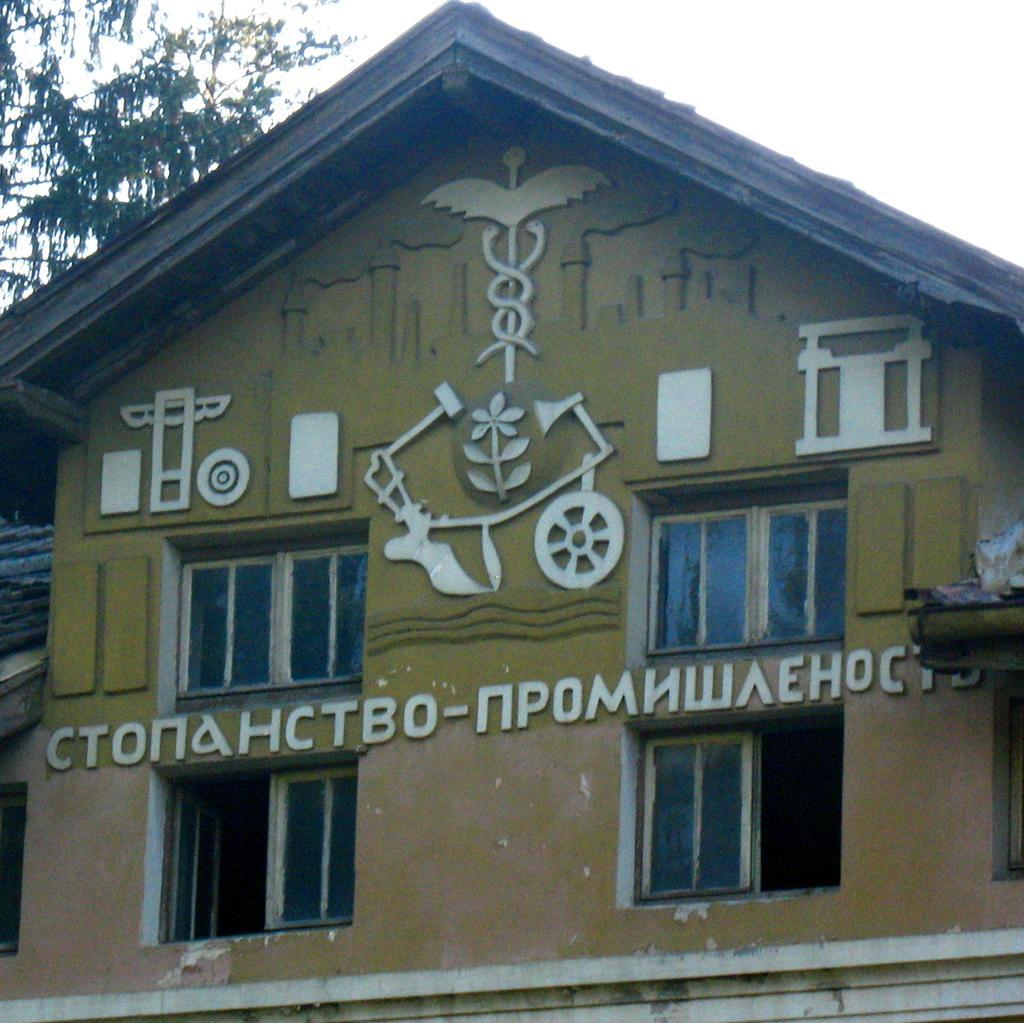Describe this image in one or two sentences. In this picture there is a house. Here we can see many windows. On the top there is a sky. On the top left corner we can see trees. 